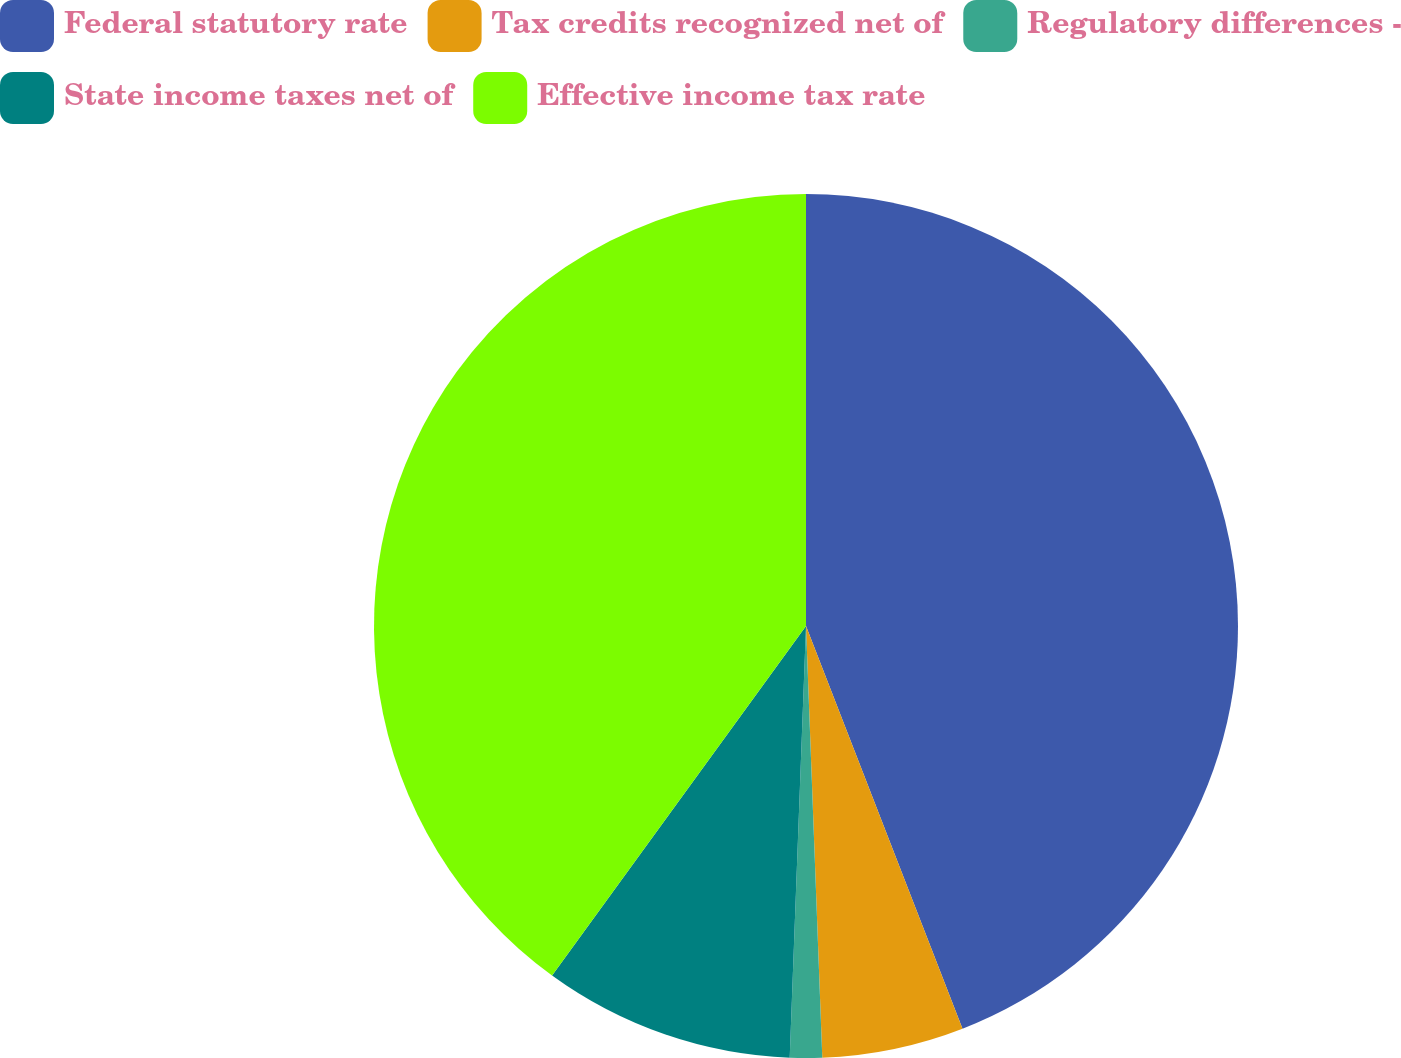Convert chart to OTSL. <chart><loc_0><loc_0><loc_500><loc_500><pie_chart><fcel>Federal statutory rate<fcel>Tax credits recognized net of<fcel>Regulatory differences -<fcel>State income taxes net of<fcel>Effective income tax rate<nl><fcel>44.1%<fcel>5.3%<fcel>1.2%<fcel>9.4%<fcel>40.0%<nl></chart> 